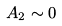Convert formula to latex. <formula><loc_0><loc_0><loc_500><loc_500>A _ { 2 } \sim 0</formula> 